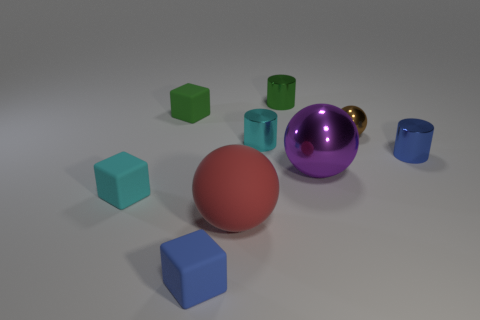Subtract 1 cylinders. How many cylinders are left? 2 Add 1 small green balls. How many objects exist? 10 Subtract all blocks. How many objects are left? 6 Add 9 red cylinders. How many red cylinders exist? 9 Subtract 1 green cubes. How many objects are left? 8 Subtract all small green cylinders. Subtract all purple things. How many objects are left? 7 Add 5 red rubber balls. How many red rubber balls are left? 6 